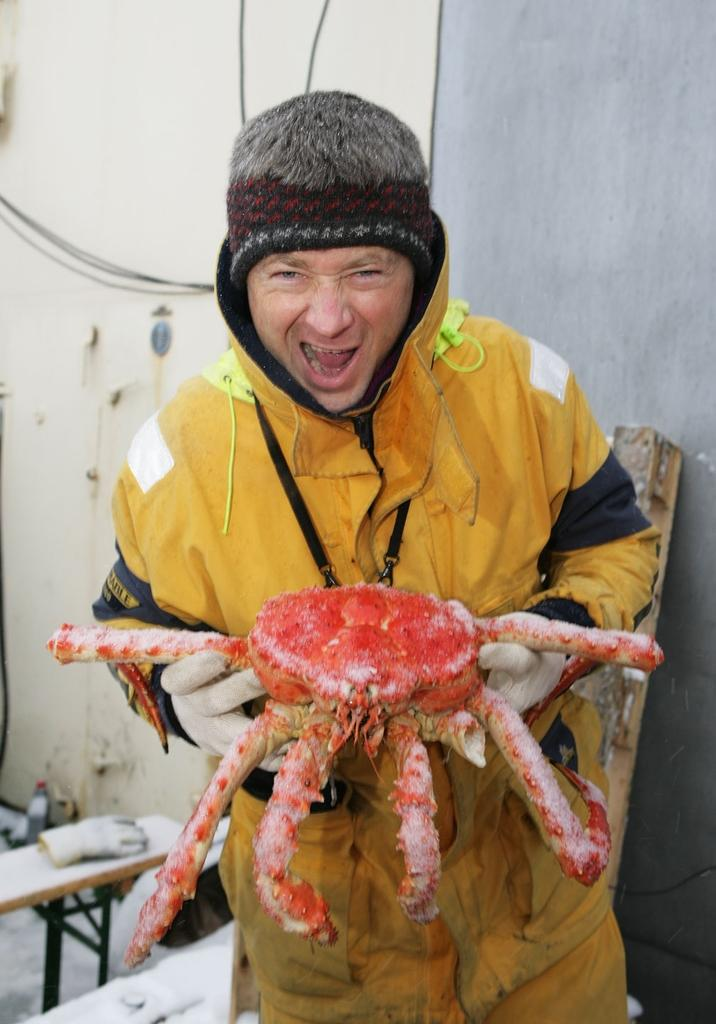What is the person in the image doing? The person is standing in the image and holding a king crab. What might the person be wearing to handle the king crab? The gloves on the benches in the background of the image could be used for handling the king crab. What can be seen in the background of the image? There is a wall visible in the background of the image. What type of harmony is being played by the crab in the image? There is no indication of music or harmony in the image; it features a person holding a king crab. How many bites has the person taken out of the crab in the image? The image does not show any bites taken out of the crab, as it is a still image. 